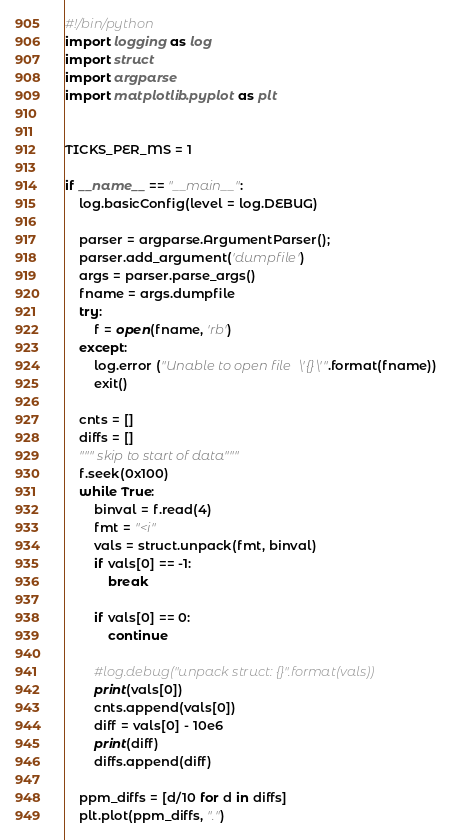Convert code to text. <code><loc_0><loc_0><loc_500><loc_500><_Python_>#!/bin/python
import logging as log
import struct
import argparse
import matplotlib.pyplot as plt


TICKS_PER_MS = 1

if __name__ == "__main__":
    log.basicConfig(level = log.DEBUG)
    
    parser = argparse.ArgumentParser();
    parser.add_argument('dumpfile')
    args = parser.parse_args()
    fname = args.dumpfile
    try:
        f = open(fname, 'rb')
    except:
        log.error ("Unable to open file \'{}\'".format(fname))
        exit()

    cnts = []    
    diffs = []
    """ skip to start of data"""
    f.seek(0x100)
    while True:
        binval = f.read(4)
        fmt = "<i"
        vals = struct.unpack(fmt, binval)
        if vals[0] == -1:
            break
        
        if vals[0] == 0:
            continue

        #log.debug("unpack struct: {}".format(vals))
        print(vals[0])
        cnts.append(vals[0])
        diff = vals[0] - 10e6
        print(diff)
        diffs.append(diff)
    
    ppm_diffs = [d/10 for d in diffs]
    plt.plot(ppm_diffs, ".")
</code> 